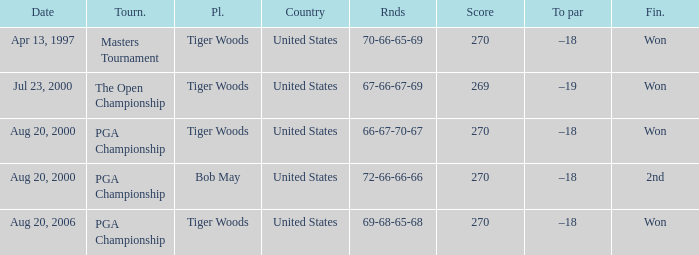What is the worst (highest) score? 270.0. 